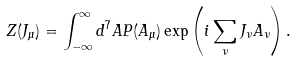Convert formula to latex. <formula><loc_0><loc_0><loc_500><loc_500>Z ( J _ { \mu } ) = \int _ { - \infty } ^ { \infty } d ^ { 7 } A P ( A _ { \mu } ) \exp \left ( i \sum _ { \nu } J _ { \nu } A _ { \nu } \right ) .</formula> 